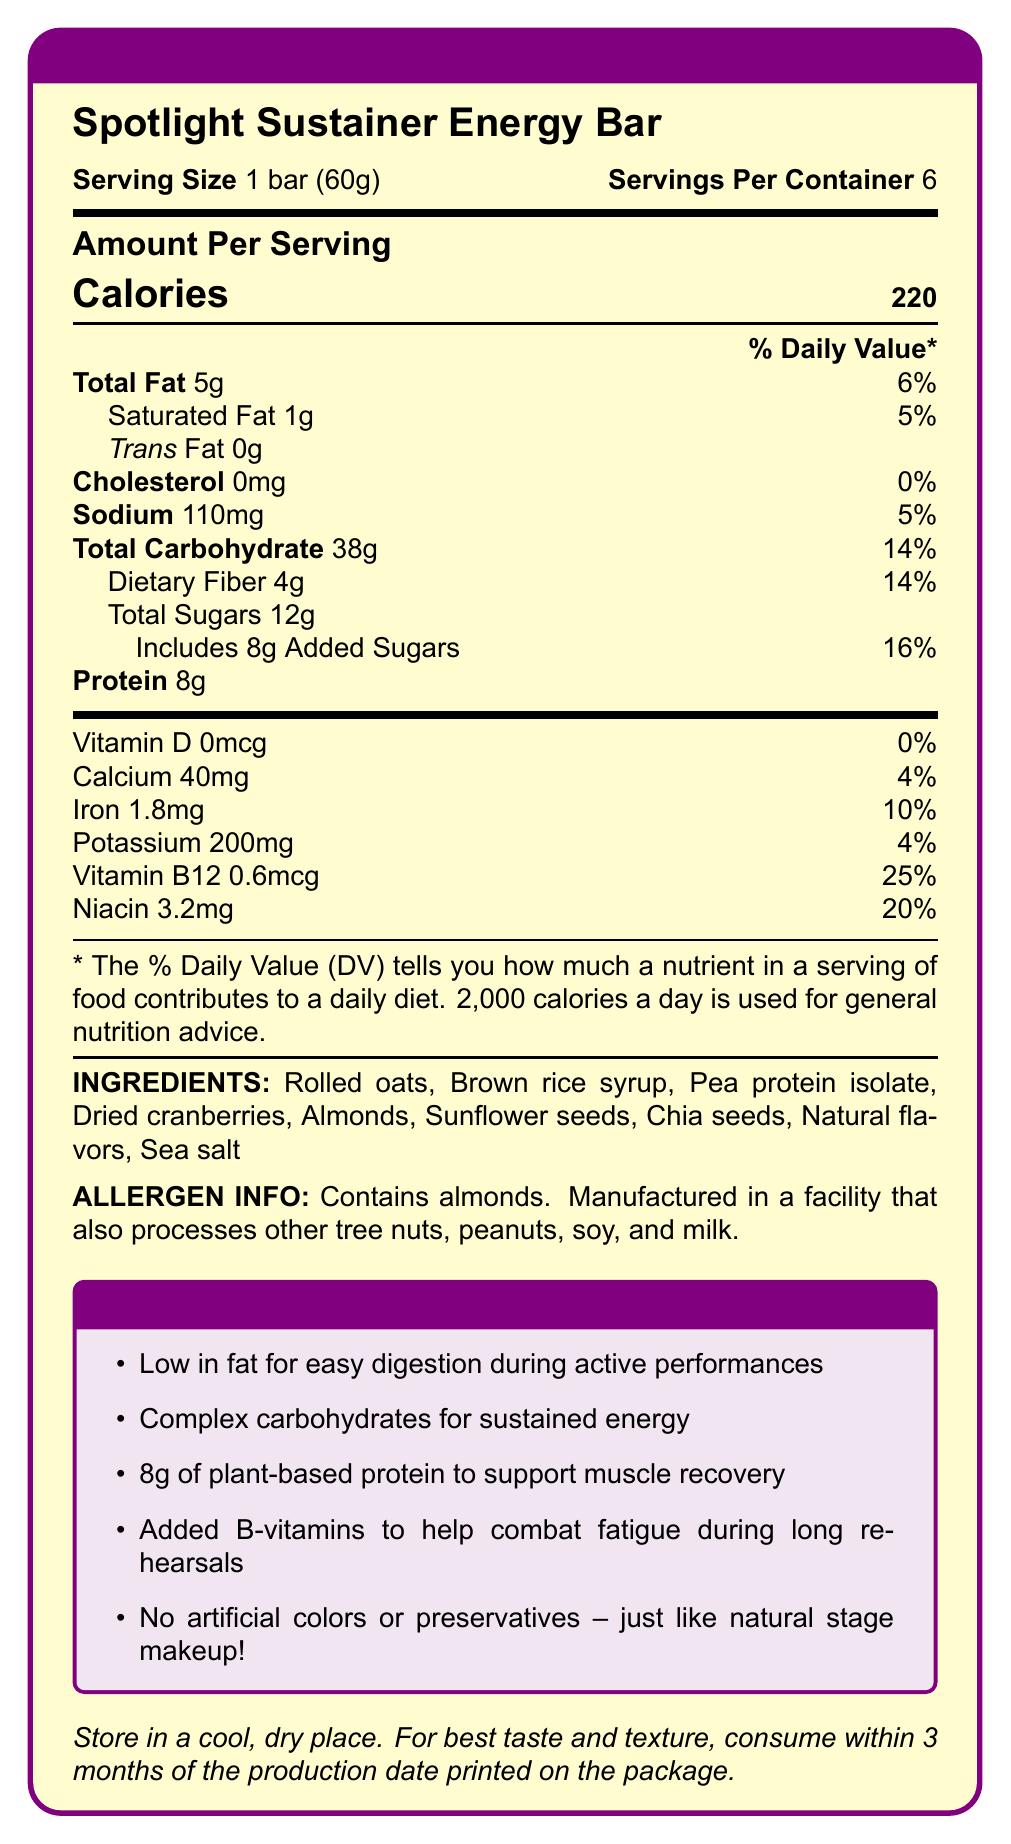what is the serving size? The document states, "Serving Size: 1 bar (60g)".
Answer: 1 bar (60g) how much protein is in one serving? The Amount Per Serving section lists "Protein 8g".
Answer: 8g what is the daily value percentage for iron? The document states, "Iron 1.8mg 10%".
Answer: 10% which ingredient is listed first? The document lists ingredients in the order: "Rolled oats, Brown rice syrup,...".
Answer: Rolled oats what is the sodium content per serving? The document states, "Sodium 110mg 5%".
Answer: 110mg how many servings are in one container? A. 4 B. 6 C. 8 D. 10 The document states, "Servings Per Container: 6".
Answer: B what is the total amount of carbohydrates in one bar? A. 30g B. 35g C. 38g D. 40g The document states, "Total Carbohydrate 38g 14%".
Answer: C does the bar contain any trans fat? The document states, "Trans Fat 0g".
Answer: No describe the main idea of the document. The document outlines the nutritional breakdown of the Spotlight Sustainer Energy Bar, highlighting its benefits for theater enthusiasts during long rehearsals with details on fat, protein, vitamins, ingredients, and allergen information.
Answer: The document provides the nutritional information for the Spotlight Sustainer Energy Bar. It highlights its low-fat content, protein, vitamins, and suitability for long rehearsals. It also lists ingredients, allergen information, and storage instructions. how many calories come from fat? The document only provides the total amount of fat per serving but does not break down the calorie content specifically from fat.
Answer: Not enough information does the energy bar contain artificial colors? The document claims, "No artificial colors or preservatives – just like natural stage makeup!".
Answer: No what allergen is specifically mentioned in the document? The document states, "Contains almonds. Manufactured in a facility that also processes other tree nuts, peanuts, soy, and milk."
Answer: Almonds what is the percentage of daily value for saturated fat? The document states, "Saturated Fat 1g 5%".
Answer: 5% how much added sugar is in one serving? The document states, "Includes 8g Added Sugars 16%".
Answer: 8g what vitamins are specifically mentioned in the document? The document lists "Vitamin D 0mcg 0%", and "Vitamin B12 0.6mcg 25%".
Answer: Vitamin D and Vitamin B12 